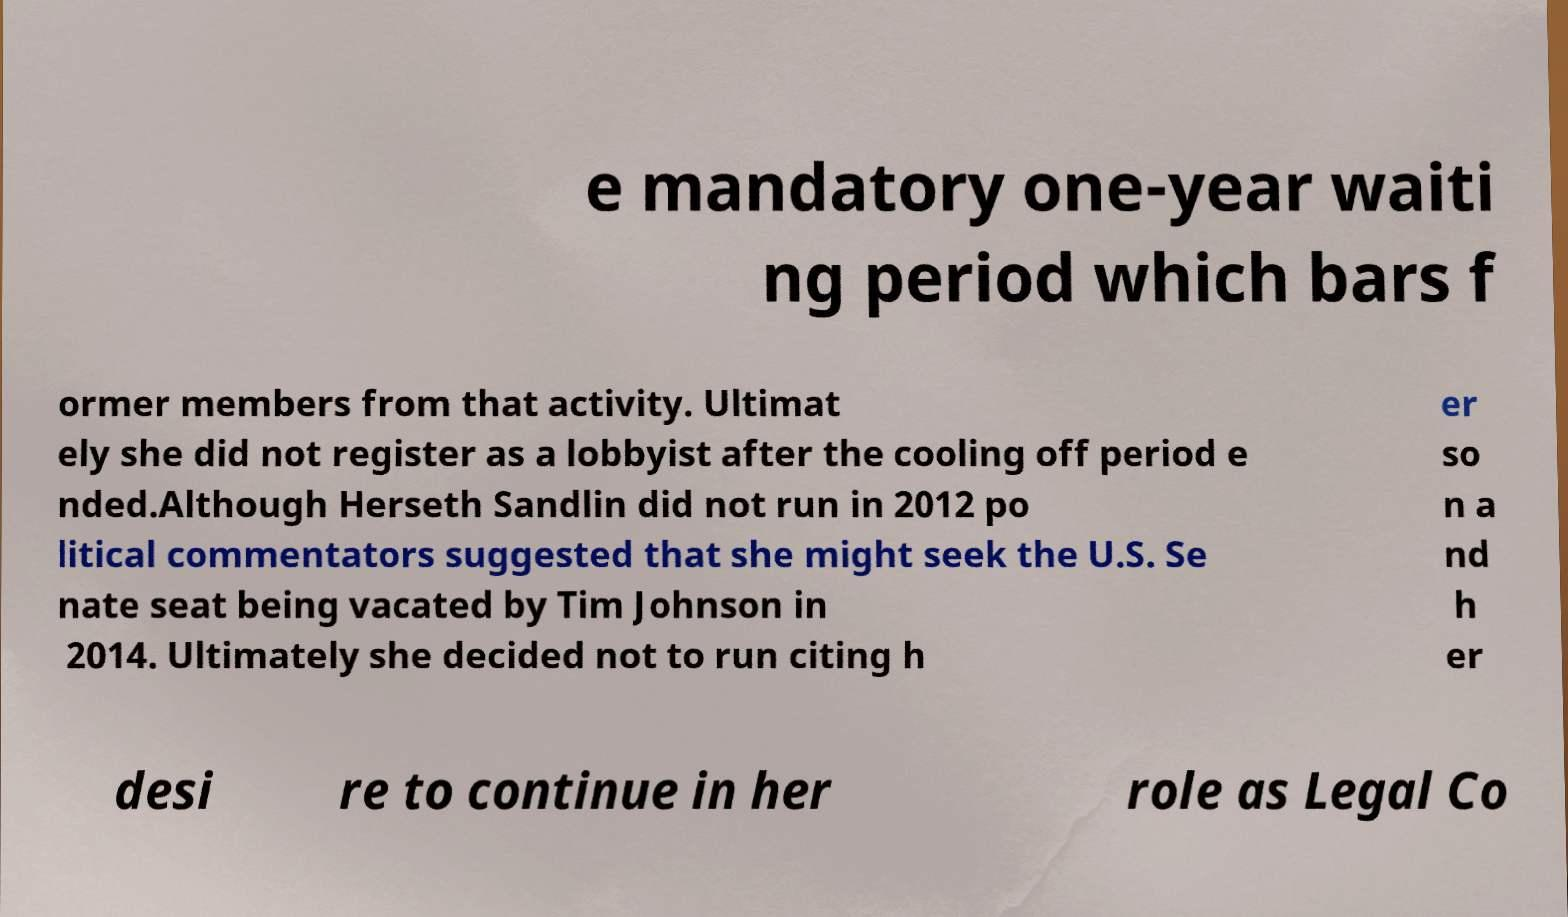Can you accurately transcribe the text from the provided image for me? e mandatory one-year waiti ng period which bars f ormer members from that activity. Ultimat ely she did not register as a lobbyist after the cooling off period e nded.Although Herseth Sandlin did not run in 2012 po litical commentators suggested that she might seek the U.S. Se nate seat being vacated by Tim Johnson in 2014. Ultimately she decided not to run citing h er so n a nd h er desi re to continue in her role as Legal Co 